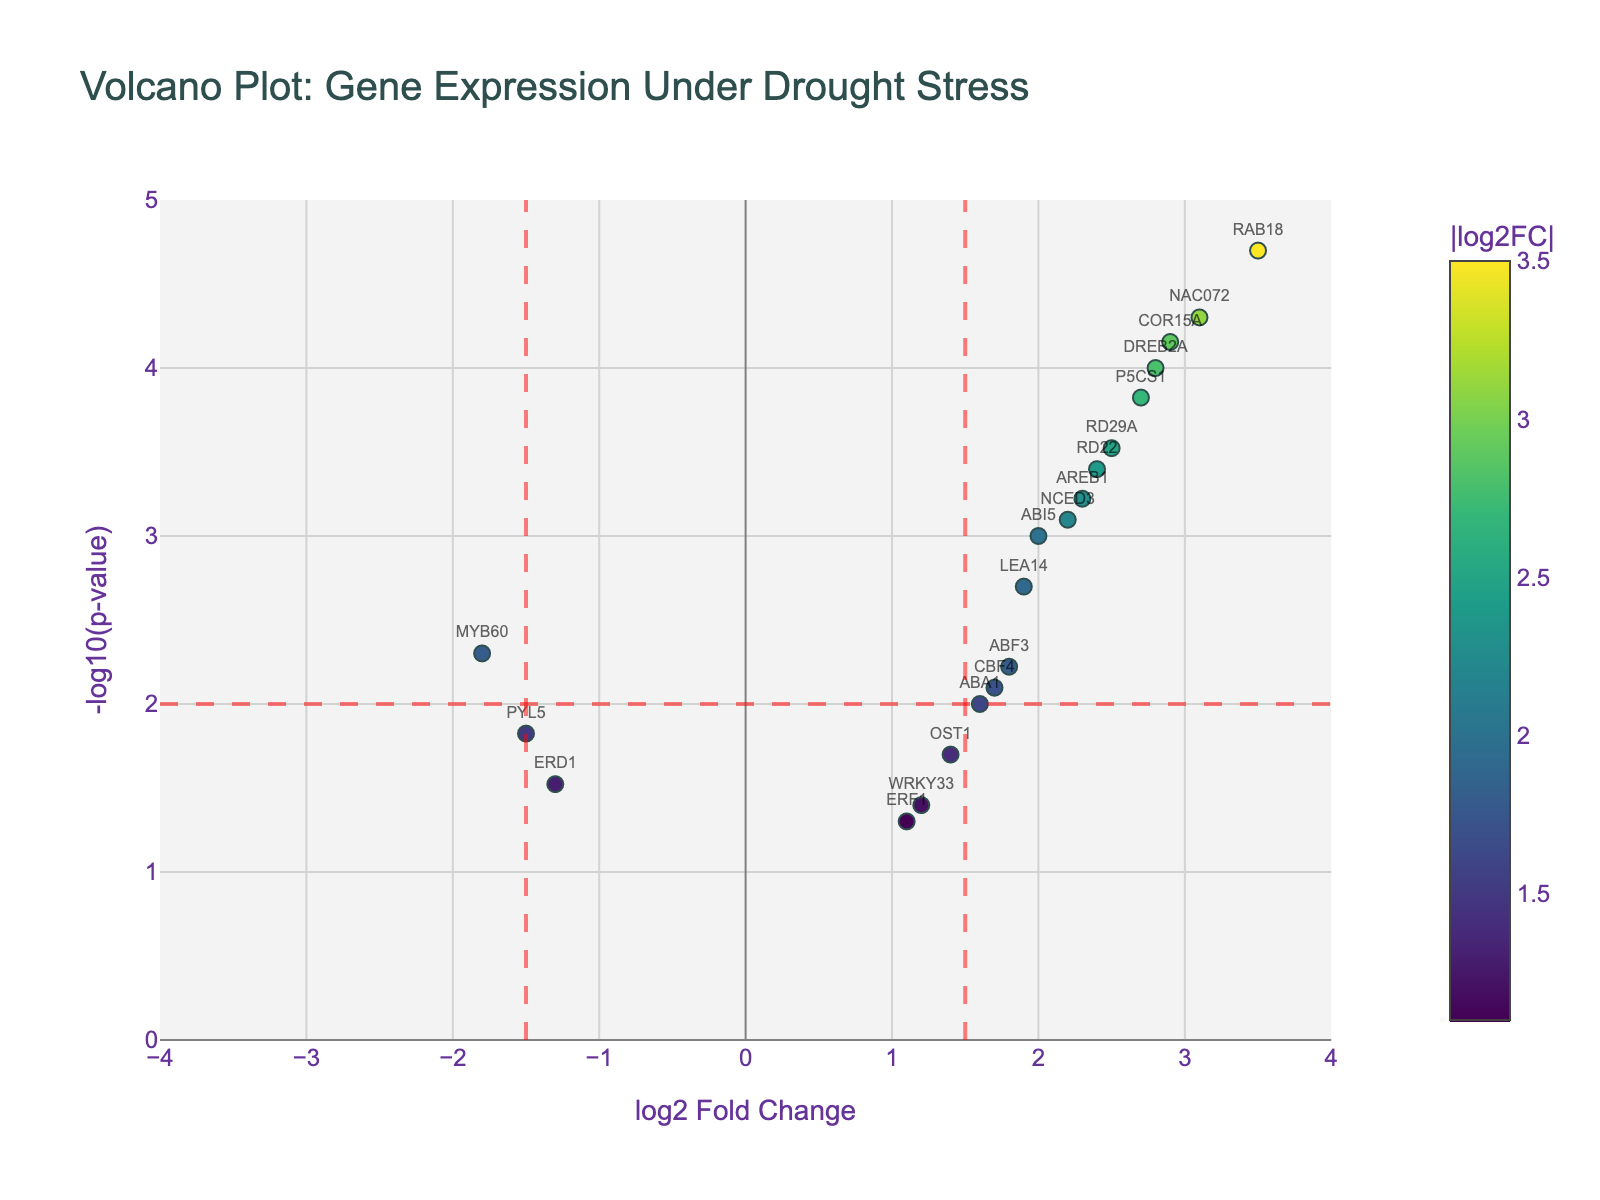Which gene has the highest log2 fold change? Locate the gene with the highest value on the x-axis where "log2 Fold Change" is labeled.
Answer: NAC072 Which gene has the smallest p-value? Find the gene represented by the highest point on the y-axis labeled "-log10(p-value)" since smaller p-values correspond to higher -log10(p-value).
Answer: RAB18 How many detected genes have a log2 fold change greater than 1.5? Count the number of data points (genes) situated to the right of the vertical threshold line at x = 1.5.
Answer: 12 Which gene has the lowest log2 fold change that is still above the significance threshold line for the p-value? Identify the valid gene to the right of the vertical threshold at x = -1.5 and above the horizontal threshold line on the y-axis for p-value significance.
Answer: ABI5 Are there any genes with negative log2 fold changes that are significantly different from zero? Look for data points (genes) to the left of the y-axis (x < 0) and above the horizontal threshold line for p-value significance on the y-axis.
Answer: ERD1, MYB60, PYL5 What is the y-axis range of the Volcano Plot? Check the vertical range labeled as "-log10(p-value)" on the y-axis to find the lowest and highest values.
Answer: 0 to 5 How many genes are labeled on the plot? Count the number of gene names displayed directly on the plot next to each data point.
Answer: 15 